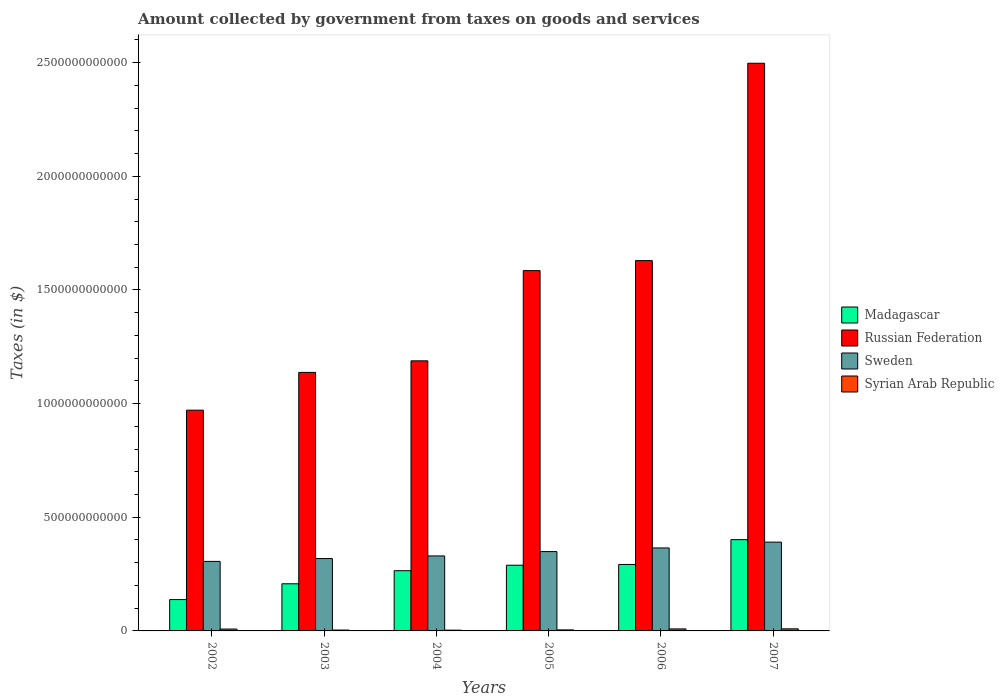How many different coloured bars are there?
Offer a very short reply. 4. How many bars are there on the 3rd tick from the right?
Offer a very short reply. 4. In how many cases, is the number of bars for a given year not equal to the number of legend labels?
Give a very brief answer. 0. What is the amount collected by government from taxes on goods and services in Madagascar in 2006?
Provide a short and direct response. 2.92e+11. Across all years, what is the maximum amount collected by government from taxes on goods and services in Sweden?
Offer a terse response. 3.91e+11. Across all years, what is the minimum amount collected by government from taxes on goods and services in Sweden?
Provide a short and direct response. 3.06e+11. What is the total amount collected by government from taxes on goods and services in Syrian Arab Republic in the graph?
Provide a succinct answer. 3.79e+1. What is the difference between the amount collected by government from taxes on goods and services in Madagascar in 2005 and that in 2007?
Keep it short and to the point. -1.12e+11. What is the difference between the amount collected by government from taxes on goods and services in Syrian Arab Republic in 2003 and the amount collected by government from taxes on goods and services in Russian Federation in 2002?
Your answer should be compact. -9.67e+11. What is the average amount collected by government from taxes on goods and services in Sweden per year?
Offer a terse response. 3.43e+11. In the year 2002, what is the difference between the amount collected by government from taxes on goods and services in Russian Federation and amount collected by government from taxes on goods and services in Sweden?
Give a very brief answer. 6.65e+11. What is the ratio of the amount collected by government from taxes on goods and services in Sweden in 2002 to that in 2004?
Your answer should be compact. 0.93. Is the amount collected by government from taxes on goods and services in Syrian Arab Republic in 2005 less than that in 2006?
Your answer should be compact. Yes. What is the difference between the highest and the second highest amount collected by government from taxes on goods and services in Sweden?
Give a very brief answer. 2.55e+1. What is the difference between the highest and the lowest amount collected by government from taxes on goods and services in Sweden?
Provide a succinct answer. 8.47e+1. Is it the case that in every year, the sum of the amount collected by government from taxes on goods and services in Russian Federation and amount collected by government from taxes on goods and services in Syrian Arab Republic is greater than the sum of amount collected by government from taxes on goods and services in Madagascar and amount collected by government from taxes on goods and services in Sweden?
Your answer should be very brief. Yes. What does the 1st bar from the left in 2006 represents?
Your answer should be compact. Madagascar. What does the 1st bar from the right in 2004 represents?
Your response must be concise. Syrian Arab Republic. Is it the case that in every year, the sum of the amount collected by government from taxes on goods and services in Russian Federation and amount collected by government from taxes on goods and services in Madagascar is greater than the amount collected by government from taxes on goods and services in Sweden?
Make the answer very short. Yes. Are all the bars in the graph horizontal?
Your answer should be compact. No. How many years are there in the graph?
Your answer should be very brief. 6. What is the difference between two consecutive major ticks on the Y-axis?
Ensure brevity in your answer.  5.00e+11. Where does the legend appear in the graph?
Your response must be concise. Center right. How are the legend labels stacked?
Make the answer very short. Vertical. What is the title of the graph?
Keep it short and to the point. Amount collected by government from taxes on goods and services. What is the label or title of the Y-axis?
Make the answer very short. Taxes (in $). What is the Taxes (in $) in Madagascar in 2002?
Your answer should be very brief. 1.38e+11. What is the Taxes (in $) of Russian Federation in 2002?
Provide a succinct answer. 9.71e+11. What is the Taxes (in $) of Sweden in 2002?
Ensure brevity in your answer.  3.06e+11. What is the Taxes (in $) in Syrian Arab Republic in 2002?
Provide a succinct answer. 8.19e+09. What is the Taxes (in $) in Madagascar in 2003?
Your response must be concise. 2.07e+11. What is the Taxes (in $) in Russian Federation in 2003?
Your response must be concise. 1.14e+12. What is the Taxes (in $) of Sweden in 2003?
Offer a very short reply. 3.18e+11. What is the Taxes (in $) of Syrian Arab Republic in 2003?
Provide a short and direct response. 3.82e+09. What is the Taxes (in $) in Madagascar in 2004?
Offer a very short reply. 2.65e+11. What is the Taxes (in $) in Russian Federation in 2004?
Provide a short and direct response. 1.19e+12. What is the Taxes (in $) of Sweden in 2004?
Ensure brevity in your answer.  3.30e+11. What is the Taxes (in $) in Syrian Arab Republic in 2004?
Make the answer very short. 3.38e+09. What is the Taxes (in $) in Madagascar in 2005?
Your response must be concise. 2.89e+11. What is the Taxes (in $) in Russian Federation in 2005?
Make the answer very short. 1.59e+12. What is the Taxes (in $) in Sweden in 2005?
Your answer should be very brief. 3.49e+11. What is the Taxes (in $) in Syrian Arab Republic in 2005?
Make the answer very short. 4.49e+09. What is the Taxes (in $) of Madagascar in 2006?
Give a very brief answer. 2.92e+11. What is the Taxes (in $) of Russian Federation in 2006?
Your answer should be compact. 1.63e+12. What is the Taxes (in $) in Sweden in 2006?
Provide a short and direct response. 3.65e+11. What is the Taxes (in $) in Syrian Arab Republic in 2006?
Your answer should be very brief. 8.83e+09. What is the Taxes (in $) of Madagascar in 2007?
Your answer should be very brief. 4.02e+11. What is the Taxes (in $) of Russian Federation in 2007?
Your response must be concise. 2.50e+12. What is the Taxes (in $) of Sweden in 2007?
Your answer should be compact. 3.91e+11. What is the Taxes (in $) in Syrian Arab Republic in 2007?
Your response must be concise. 9.14e+09. Across all years, what is the maximum Taxes (in $) of Madagascar?
Give a very brief answer. 4.02e+11. Across all years, what is the maximum Taxes (in $) in Russian Federation?
Your answer should be very brief. 2.50e+12. Across all years, what is the maximum Taxes (in $) in Sweden?
Keep it short and to the point. 3.91e+11. Across all years, what is the maximum Taxes (in $) of Syrian Arab Republic?
Give a very brief answer. 9.14e+09. Across all years, what is the minimum Taxes (in $) of Madagascar?
Ensure brevity in your answer.  1.38e+11. Across all years, what is the minimum Taxes (in $) in Russian Federation?
Give a very brief answer. 9.71e+11. Across all years, what is the minimum Taxes (in $) of Sweden?
Your answer should be very brief. 3.06e+11. Across all years, what is the minimum Taxes (in $) of Syrian Arab Republic?
Your answer should be very brief. 3.38e+09. What is the total Taxes (in $) of Madagascar in the graph?
Your answer should be very brief. 1.59e+12. What is the total Taxes (in $) in Russian Federation in the graph?
Your answer should be compact. 9.01e+12. What is the total Taxes (in $) of Sweden in the graph?
Make the answer very short. 2.06e+12. What is the total Taxes (in $) of Syrian Arab Republic in the graph?
Provide a succinct answer. 3.79e+1. What is the difference between the Taxes (in $) in Madagascar in 2002 and that in 2003?
Offer a terse response. -6.95e+1. What is the difference between the Taxes (in $) of Russian Federation in 2002 and that in 2003?
Ensure brevity in your answer.  -1.66e+11. What is the difference between the Taxes (in $) of Sweden in 2002 and that in 2003?
Keep it short and to the point. -1.25e+1. What is the difference between the Taxes (in $) of Syrian Arab Republic in 2002 and that in 2003?
Keep it short and to the point. 4.37e+09. What is the difference between the Taxes (in $) in Madagascar in 2002 and that in 2004?
Your answer should be very brief. -1.27e+11. What is the difference between the Taxes (in $) in Russian Federation in 2002 and that in 2004?
Your response must be concise. -2.17e+11. What is the difference between the Taxes (in $) of Sweden in 2002 and that in 2004?
Your answer should be compact. -2.41e+1. What is the difference between the Taxes (in $) in Syrian Arab Republic in 2002 and that in 2004?
Your answer should be very brief. 4.81e+09. What is the difference between the Taxes (in $) in Madagascar in 2002 and that in 2005?
Your answer should be very brief. -1.51e+11. What is the difference between the Taxes (in $) of Russian Federation in 2002 and that in 2005?
Give a very brief answer. -6.14e+11. What is the difference between the Taxes (in $) of Sweden in 2002 and that in 2005?
Give a very brief answer. -4.31e+1. What is the difference between the Taxes (in $) of Syrian Arab Republic in 2002 and that in 2005?
Provide a short and direct response. 3.70e+09. What is the difference between the Taxes (in $) of Madagascar in 2002 and that in 2006?
Make the answer very short. -1.54e+11. What is the difference between the Taxes (in $) in Russian Federation in 2002 and that in 2006?
Offer a very short reply. -6.58e+11. What is the difference between the Taxes (in $) of Sweden in 2002 and that in 2006?
Provide a short and direct response. -5.92e+1. What is the difference between the Taxes (in $) in Syrian Arab Republic in 2002 and that in 2006?
Ensure brevity in your answer.  -6.39e+08. What is the difference between the Taxes (in $) of Madagascar in 2002 and that in 2007?
Your answer should be compact. -2.64e+11. What is the difference between the Taxes (in $) of Russian Federation in 2002 and that in 2007?
Give a very brief answer. -1.53e+12. What is the difference between the Taxes (in $) in Sweden in 2002 and that in 2007?
Make the answer very short. -8.47e+1. What is the difference between the Taxes (in $) of Syrian Arab Republic in 2002 and that in 2007?
Keep it short and to the point. -9.52e+08. What is the difference between the Taxes (in $) in Madagascar in 2003 and that in 2004?
Provide a succinct answer. -5.76e+1. What is the difference between the Taxes (in $) of Russian Federation in 2003 and that in 2004?
Make the answer very short. -5.08e+1. What is the difference between the Taxes (in $) in Sweden in 2003 and that in 2004?
Your response must be concise. -1.16e+1. What is the difference between the Taxes (in $) in Syrian Arab Republic in 2003 and that in 2004?
Provide a short and direct response. 4.42e+08. What is the difference between the Taxes (in $) of Madagascar in 2003 and that in 2005?
Your response must be concise. -8.17e+1. What is the difference between the Taxes (in $) in Russian Federation in 2003 and that in 2005?
Provide a succinct answer. -4.48e+11. What is the difference between the Taxes (in $) in Sweden in 2003 and that in 2005?
Provide a short and direct response. -3.07e+1. What is the difference between the Taxes (in $) of Syrian Arab Republic in 2003 and that in 2005?
Your response must be concise. -6.73e+08. What is the difference between the Taxes (in $) in Madagascar in 2003 and that in 2006?
Provide a succinct answer. -8.50e+1. What is the difference between the Taxes (in $) of Russian Federation in 2003 and that in 2006?
Keep it short and to the point. -4.92e+11. What is the difference between the Taxes (in $) of Sweden in 2003 and that in 2006?
Offer a very short reply. -4.67e+1. What is the difference between the Taxes (in $) of Syrian Arab Republic in 2003 and that in 2006?
Ensure brevity in your answer.  -5.01e+09. What is the difference between the Taxes (in $) of Madagascar in 2003 and that in 2007?
Provide a succinct answer. -1.94e+11. What is the difference between the Taxes (in $) of Russian Federation in 2003 and that in 2007?
Ensure brevity in your answer.  -1.36e+12. What is the difference between the Taxes (in $) of Sweden in 2003 and that in 2007?
Your answer should be very brief. -7.22e+1. What is the difference between the Taxes (in $) in Syrian Arab Republic in 2003 and that in 2007?
Provide a short and direct response. -5.32e+09. What is the difference between the Taxes (in $) of Madagascar in 2004 and that in 2005?
Offer a terse response. -2.41e+1. What is the difference between the Taxes (in $) of Russian Federation in 2004 and that in 2005?
Keep it short and to the point. -3.97e+11. What is the difference between the Taxes (in $) in Sweden in 2004 and that in 2005?
Offer a very short reply. -1.91e+1. What is the difference between the Taxes (in $) in Syrian Arab Republic in 2004 and that in 2005?
Offer a terse response. -1.12e+09. What is the difference between the Taxes (in $) in Madagascar in 2004 and that in 2006?
Make the answer very short. -2.74e+1. What is the difference between the Taxes (in $) of Russian Federation in 2004 and that in 2006?
Give a very brief answer. -4.41e+11. What is the difference between the Taxes (in $) of Sweden in 2004 and that in 2006?
Ensure brevity in your answer.  -3.51e+1. What is the difference between the Taxes (in $) in Syrian Arab Republic in 2004 and that in 2006?
Your answer should be compact. -5.45e+09. What is the difference between the Taxes (in $) in Madagascar in 2004 and that in 2007?
Offer a very short reply. -1.37e+11. What is the difference between the Taxes (in $) in Russian Federation in 2004 and that in 2007?
Your response must be concise. -1.31e+12. What is the difference between the Taxes (in $) in Sweden in 2004 and that in 2007?
Ensure brevity in your answer.  -6.07e+1. What is the difference between the Taxes (in $) of Syrian Arab Republic in 2004 and that in 2007?
Your answer should be compact. -5.77e+09. What is the difference between the Taxes (in $) in Madagascar in 2005 and that in 2006?
Ensure brevity in your answer.  -3.30e+09. What is the difference between the Taxes (in $) of Russian Federation in 2005 and that in 2006?
Your answer should be compact. -4.41e+1. What is the difference between the Taxes (in $) of Sweden in 2005 and that in 2006?
Your answer should be compact. -1.60e+1. What is the difference between the Taxes (in $) in Syrian Arab Republic in 2005 and that in 2006?
Offer a terse response. -4.34e+09. What is the difference between the Taxes (in $) of Madagascar in 2005 and that in 2007?
Offer a terse response. -1.12e+11. What is the difference between the Taxes (in $) of Russian Federation in 2005 and that in 2007?
Provide a succinct answer. -9.12e+11. What is the difference between the Taxes (in $) in Sweden in 2005 and that in 2007?
Provide a short and direct response. -4.16e+1. What is the difference between the Taxes (in $) of Syrian Arab Republic in 2005 and that in 2007?
Your answer should be very brief. -4.65e+09. What is the difference between the Taxes (in $) in Madagascar in 2006 and that in 2007?
Your answer should be compact. -1.09e+11. What is the difference between the Taxes (in $) in Russian Federation in 2006 and that in 2007?
Provide a short and direct response. -8.68e+11. What is the difference between the Taxes (in $) in Sweden in 2006 and that in 2007?
Make the answer very short. -2.55e+1. What is the difference between the Taxes (in $) of Syrian Arab Republic in 2006 and that in 2007?
Make the answer very short. -3.13e+08. What is the difference between the Taxes (in $) in Madagascar in 2002 and the Taxes (in $) in Russian Federation in 2003?
Ensure brevity in your answer.  -9.99e+11. What is the difference between the Taxes (in $) in Madagascar in 2002 and the Taxes (in $) in Sweden in 2003?
Provide a short and direct response. -1.80e+11. What is the difference between the Taxes (in $) of Madagascar in 2002 and the Taxes (in $) of Syrian Arab Republic in 2003?
Provide a succinct answer. 1.34e+11. What is the difference between the Taxes (in $) of Russian Federation in 2002 and the Taxes (in $) of Sweden in 2003?
Provide a succinct answer. 6.53e+11. What is the difference between the Taxes (in $) in Russian Federation in 2002 and the Taxes (in $) in Syrian Arab Republic in 2003?
Offer a terse response. 9.67e+11. What is the difference between the Taxes (in $) in Sweden in 2002 and the Taxes (in $) in Syrian Arab Republic in 2003?
Offer a very short reply. 3.02e+11. What is the difference between the Taxes (in $) in Madagascar in 2002 and the Taxes (in $) in Russian Federation in 2004?
Offer a very short reply. -1.05e+12. What is the difference between the Taxes (in $) of Madagascar in 2002 and the Taxes (in $) of Sweden in 2004?
Your answer should be very brief. -1.92e+11. What is the difference between the Taxes (in $) of Madagascar in 2002 and the Taxes (in $) of Syrian Arab Republic in 2004?
Offer a terse response. 1.35e+11. What is the difference between the Taxes (in $) in Russian Federation in 2002 and the Taxes (in $) in Sweden in 2004?
Your response must be concise. 6.41e+11. What is the difference between the Taxes (in $) of Russian Federation in 2002 and the Taxes (in $) of Syrian Arab Republic in 2004?
Your answer should be very brief. 9.68e+11. What is the difference between the Taxes (in $) of Sweden in 2002 and the Taxes (in $) of Syrian Arab Republic in 2004?
Your answer should be compact. 3.02e+11. What is the difference between the Taxes (in $) in Madagascar in 2002 and the Taxes (in $) in Russian Federation in 2005?
Give a very brief answer. -1.45e+12. What is the difference between the Taxes (in $) in Madagascar in 2002 and the Taxes (in $) in Sweden in 2005?
Give a very brief answer. -2.11e+11. What is the difference between the Taxes (in $) of Madagascar in 2002 and the Taxes (in $) of Syrian Arab Republic in 2005?
Make the answer very short. 1.33e+11. What is the difference between the Taxes (in $) of Russian Federation in 2002 and the Taxes (in $) of Sweden in 2005?
Make the answer very short. 6.22e+11. What is the difference between the Taxes (in $) of Russian Federation in 2002 and the Taxes (in $) of Syrian Arab Republic in 2005?
Provide a short and direct response. 9.67e+11. What is the difference between the Taxes (in $) of Sweden in 2002 and the Taxes (in $) of Syrian Arab Republic in 2005?
Your answer should be compact. 3.01e+11. What is the difference between the Taxes (in $) in Madagascar in 2002 and the Taxes (in $) in Russian Federation in 2006?
Provide a short and direct response. -1.49e+12. What is the difference between the Taxes (in $) of Madagascar in 2002 and the Taxes (in $) of Sweden in 2006?
Provide a short and direct response. -2.27e+11. What is the difference between the Taxes (in $) of Madagascar in 2002 and the Taxes (in $) of Syrian Arab Republic in 2006?
Your response must be concise. 1.29e+11. What is the difference between the Taxes (in $) of Russian Federation in 2002 and the Taxes (in $) of Sweden in 2006?
Your answer should be compact. 6.06e+11. What is the difference between the Taxes (in $) in Russian Federation in 2002 and the Taxes (in $) in Syrian Arab Republic in 2006?
Give a very brief answer. 9.62e+11. What is the difference between the Taxes (in $) of Sweden in 2002 and the Taxes (in $) of Syrian Arab Republic in 2006?
Provide a succinct answer. 2.97e+11. What is the difference between the Taxes (in $) of Madagascar in 2002 and the Taxes (in $) of Russian Federation in 2007?
Make the answer very short. -2.36e+12. What is the difference between the Taxes (in $) in Madagascar in 2002 and the Taxes (in $) in Sweden in 2007?
Your answer should be compact. -2.53e+11. What is the difference between the Taxes (in $) of Madagascar in 2002 and the Taxes (in $) of Syrian Arab Republic in 2007?
Provide a succinct answer. 1.29e+11. What is the difference between the Taxes (in $) of Russian Federation in 2002 and the Taxes (in $) of Sweden in 2007?
Offer a terse response. 5.81e+11. What is the difference between the Taxes (in $) of Russian Federation in 2002 and the Taxes (in $) of Syrian Arab Republic in 2007?
Give a very brief answer. 9.62e+11. What is the difference between the Taxes (in $) of Sweden in 2002 and the Taxes (in $) of Syrian Arab Republic in 2007?
Give a very brief answer. 2.97e+11. What is the difference between the Taxes (in $) in Madagascar in 2003 and the Taxes (in $) in Russian Federation in 2004?
Provide a succinct answer. -9.81e+11. What is the difference between the Taxes (in $) in Madagascar in 2003 and the Taxes (in $) in Sweden in 2004?
Make the answer very short. -1.23e+11. What is the difference between the Taxes (in $) of Madagascar in 2003 and the Taxes (in $) of Syrian Arab Republic in 2004?
Your response must be concise. 2.04e+11. What is the difference between the Taxes (in $) in Russian Federation in 2003 and the Taxes (in $) in Sweden in 2004?
Offer a very short reply. 8.07e+11. What is the difference between the Taxes (in $) in Russian Federation in 2003 and the Taxes (in $) in Syrian Arab Republic in 2004?
Provide a succinct answer. 1.13e+12. What is the difference between the Taxes (in $) in Sweden in 2003 and the Taxes (in $) in Syrian Arab Republic in 2004?
Make the answer very short. 3.15e+11. What is the difference between the Taxes (in $) of Madagascar in 2003 and the Taxes (in $) of Russian Federation in 2005?
Your answer should be very brief. -1.38e+12. What is the difference between the Taxes (in $) of Madagascar in 2003 and the Taxes (in $) of Sweden in 2005?
Provide a short and direct response. -1.42e+11. What is the difference between the Taxes (in $) in Madagascar in 2003 and the Taxes (in $) in Syrian Arab Republic in 2005?
Keep it short and to the point. 2.03e+11. What is the difference between the Taxes (in $) of Russian Federation in 2003 and the Taxes (in $) of Sweden in 2005?
Make the answer very short. 7.88e+11. What is the difference between the Taxes (in $) of Russian Federation in 2003 and the Taxes (in $) of Syrian Arab Republic in 2005?
Your answer should be compact. 1.13e+12. What is the difference between the Taxes (in $) in Sweden in 2003 and the Taxes (in $) in Syrian Arab Republic in 2005?
Provide a succinct answer. 3.14e+11. What is the difference between the Taxes (in $) in Madagascar in 2003 and the Taxes (in $) in Russian Federation in 2006?
Keep it short and to the point. -1.42e+12. What is the difference between the Taxes (in $) in Madagascar in 2003 and the Taxes (in $) in Sweden in 2006?
Make the answer very short. -1.58e+11. What is the difference between the Taxes (in $) in Madagascar in 2003 and the Taxes (in $) in Syrian Arab Republic in 2006?
Give a very brief answer. 1.99e+11. What is the difference between the Taxes (in $) in Russian Federation in 2003 and the Taxes (in $) in Sweden in 2006?
Offer a terse response. 7.72e+11. What is the difference between the Taxes (in $) in Russian Federation in 2003 and the Taxes (in $) in Syrian Arab Republic in 2006?
Your response must be concise. 1.13e+12. What is the difference between the Taxes (in $) in Sweden in 2003 and the Taxes (in $) in Syrian Arab Republic in 2006?
Your answer should be compact. 3.10e+11. What is the difference between the Taxes (in $) in Madagascar in 2003 and the Taxes (in $) in Russian Federation in 2007?
Provide a short and direct response. -2.29e+12. What is the difference between the Taxes (in $) of Madagascar in 2003 and the Taxes (in $) of Sweden in 2007?
Your response must be concise. -1.83e+11. What is the difference between the Taxes (in $) in Madagascar in 2003 and the Taxes (in $) in Syrian Arab Republic in 2007?
Offer a very short reply. 1.98e+11. What is the difference between the Taxes (in $) in Russian Federation in 2003 and the Taxes (in $) in Sweden in 2007?
Make the answer very short. 7.47e+11. What is the difference between the Taxes (in $) of Russian Federation in 2003 and the Taxes (in $) of Syrian Arab Republic in 2007?
Give a very brief answer. 1.13e+12. What is the difference between the Taxes (in $) of Sweden in 2003 and the Taxes (in $) of Syrian Arab Republic in 2007?
Ensure brevity in your answer.  3.09e+11. What is the difference between the Taxes (in $) in Madagascar in 2004 and the Taxes (in $) in Russian Federation in 2005?
Offer a very short reply. -1.32e+12. What is the difference between the Taxes (in $) of Madagascar in 2004 and the Taxes (in $) of Sweden in 2005?
Keep it short and to the point. -8.40e+1. What is the difference between the Taxes (in $) of Madagascar in 2004 and the Taxes (in $) of Syrian Arab Republic in 2005?
Provide a short and direct response. 2.60e+11. What is the difference between the Taxes (in $) in Russian Federation in 2004 and the Taxes (in $) in Sweden in 2005?
Offer a terse response. 8.39e+11. What is the difference between the Taxes (in $) in Russian Federation in 2004 and the Taxes (in $) in Syrian Arab Republic in 2005?
Provide a succinct answer. 1.18e+12. What is the difference between the Taxes (in $) of Sweden in 2004 and the Taxes (in $) of Syrian Arab Republic in 2005?
Offer a very short reply. 3.25e+11. What is the difference between the Taxes (in $) in Madagascar in 2004 and the Taxes (in $) in Russian Federation in 2006?
Your answer should be compact. -1.36e+12. What is the difference between the Taxes (in $) of Madagascar in 2004 and the Taxes (in $) of Sweden in 2006?
Your answer should be very brief. -1.00e+11. What is the difference between the Taxes (in $) of Madagascar in 2004 and the Taxes (in $) of Syrian Arab Republic in 2006?
Make the answer very short. 2.56e+11. What is the difference between the Taxes (in $) of Russian Federation in 2004 and the Taxes (in $) of Sweden in 2006?
Your answer should be very brief. 8.23e+11. What is the difference between the Taxes (in $) in Russian Federation in 2004 and the Taxes (in $) in Syrian Arab Republic in 2006?
Your response must be concise. 1.18e+12. What is the difference between the Taxes (in $) in Sweden in 2004 and the Taxes (in $) in Syrian Arab Republic in 2006?
Make the answer very short. 3.21e+11. What is the difference between the Taxes (in $) of Madagascar in 2004 and the Taxes (in $) of Russian Federation in 2007?
Give a very brief answer. -2.23e+12. What is the difference between the Taxes (in $) of Madagascar in 2004 and the Taxes (in $) of Sweden in 2007?
Ensure brevity in your answer.  -1.26e+11. What is the difference between the Taxes (in $) of Madagascar in 2004 and the Taxes (in $) of Syrian Arab Republic in 2007?
Provide a succinct answer. 2.56e+11. What is the difference between the Taxes (in $) of Russian Federation in 2004 and the Taxes (in $) of Sweden in 2007?
Give a very brief answer. 7.98e+11. What is the difference between the Taxes (in $) of Russian Federation in 2004 and the Taxes (in $) of Syrian Arab Republic in 2007?
Your answer should be very brief. 1.18e+12. What is the difference between the Taxes (in $) of Sweden in 2004 and the Taxes (in $) of Syrian Arab Republic in 2007?
Offer a terse response. 3.21e+11. What is the difference between the Taxes (in $) of Madagascar in 2005 and the Taxes (in $) of Russian Federation in 2006?
Your response must be concise. -1.34e+12. What is the difference between the Taxes (in $) of Madagascar in 2005 and the Taxes (in $) of Sweden in 2006?
Offer a very short reply. -7.60e+1. What is the difference between the Taxes (in $) in Madagascar in 2005 and the Taxes (in $) in Syrian Arab Republic in 2006?
Provide a succinct answer. 2.80e+11. What is the difference between the Taxes (in $) in Russian Federation in 2005 and the Taxes (in $) in Sweden in 2006?
Give a very brief answer. 1.22e+12. What is the difference between the Taxes (in $) of Russian Federation in 2005 and the Taxes (in $) of Syrian Arab Republic in 2006?
Keep it short and to the point. 1.58e+12. What is the difference between the Taxes (in $) in Sweden in 2005 and the Taxes (in $) in Syrian Arab Republic in 2006?
Offer a terse response. 3.40e+11. What is the difference between the Taxes (in $) of Madagascar in 2005 and the Taxes (in $) of Russian Federation in 2007?
Ensure brevity in your answer.  -2.21e+12. What is the difference between the Taxes (in $) in Madagascar in 2005 and the Taxes (in $) in Sweden in 2007?
Make the answer very short. -1.02e+11. What is the difference between the Taxes (in $) of Madagascar in 2005 and the Taxes (in $) of Syrian Arab Republic in 2007?
Offer a terse response. 2.80e+11. What is the difference between the Taxes (in $) in Russian Federation in 2005 and the Taxes (in $) in Sweden in 2007?
Provide a short and direct response. 1.19e+12. What is the difference between the Taxes (in $) of Russian Federation in 2005 and the Taxes (in $) of Syrian Arab Republic in 2007?
Ensure brevity in your answer.  1.58e+12. What is the difference between the Taxes (in $) in Sweden in 2005 and the Taxes (in $) in Syrian Arab Republic in 2007?
Keep it short and to the point. 3.40e+11. What is the difference between the Taxes (in $) in Madagascar in 2006 and the Taxes (in $) in Russian Federation in 2007?
Keep it short and to the point. -2.20e+12. What is the difference between the Taxes (in $) of Madagascar in 2006 and the Taxes (in $) of Sweden in 2007?
Make the answer very short. -9.82e+1. What is the difference between the Taxes (in $) of Madagascar in 2006 and the Taxes (in $) of Syrian Arab Republic in 2007?
Your answer should be compact. 2.83e+11. What is the difference between the Taxes (in $) of Russian Federation in 2006 and the Taxes (in $) of Sweden in 2007?
Your answer should be very brief. 1.24e+12. What is the difference between the Taxes (in $) of Russian Federation in 2006 and the Taxes (in $) of Syrian Arab Republic in 2007?
Give a very brief answer. 1.62e+12. What is the difference between the Taxes (in $) of Sweden in 2006 and the Taxes (in $) of Syrian Arab Republic in 2007?
Provide a succinct answer. 3.56e+11. What is the average Taxes (in $) of Madagascar per year?
Your response must be concise. 2.66e+11. What is the average Taxes (in $) in Russian Federation per year?
Ensure brevity in your answer.  1.50e+12. What is the average Taxes (in $) in Sweden per year?
Make the answer very short. 3.43e+11. What is the average Taxes (in $) in Syrian Arab Republic per year?
Offer a terse response. 6.31e+09. In the year 2002, what is the difference between the Taxes (in $) in Madagascar and Taxes (in $) in Russian Federation?
Provide a short and direct response. -8.33e+11. In the year 2002, what is the difference between the Taxes (in $) in Madagascar and Taxes (in $) in Sweden?
Your answer should be compact. -1.68e+11. In the year 2002, what is the difference between the Taxes (in $) in Madagascar and Taxes (in $) in Syrian Arab Republic?
Your response must be concise. 1.30e+11. In the year 2002, what is the difference between the Taxes (in $) of Russian Federation and Taxes (in $) of Sweden?
Keep it short and to the point. 6.65e+11. In the year 2002, what is the difference between the Taxes (in $) of Russian Federation and Taxes (in $) of Syrian Arab Republic?
Offer a very short reply. 9.63e+11. In the year 2002, what is the difference between the Taxes (in $) of Sweden and Taxes (in $) of Syrian Arab Republic?
Offer a terse response. 2.98e+11. In the year 2003, what is the difference between the Taxes (in $) of Madagascar and Taxes (in $) of Russian Federation?
Your answer should be compact. -9.30e+11. In the year 2003, what is the difference between the Taxes (in $) of Madagascar and Taxes (in $) of Sweden?
Provide a succinct answer. -1.11e+11. In the year 2003, what is the difference between the Taxes (in $) in Madagascar and Taxes (in $) in Syrian Arab Republic?
Offer a very short reply. 2.04e+11. In the year 2003, what is the difference between the Taxes (in $) of Russian Federation and Taxes (in $) of Sweden?
Keep it short and to the point. 8.19e+11. In the year 2003, what is the difference between the Taxes (in $) in Russian Federation and Taxes (in $) in Syrian Arab Republic?
Offer a very short reply. 1.13e+12. In the year 2003, what is the difference between the Taxes (in $) of Sweden and Taxes (in $) of Syrian Arab Republic?
Give a very brief answer. 3.15e+11. In the year 2004, what is the difference between the Taxes (in $) in Madagascar and Taxes (in $) in Russian Federation?
Offer a terse response. -9.23e+11. In the year 2004, what is the difference between the Taxes (in $) in Madagascar and Taxes (in $) in Sweden?
Make the answer very short. -6.50e+1. In the year 2004, what is the difference between the Taxes (in $) in Madagascar and Taxes (in $) in Syrian Arab Republic?
Provide a succinct answer. 2.62e+11. In the year 2004, what is the difference between the Taxes (in $) in Russian Federation and Taxes (in $) in Sweden?
Your answer should be very brief. 8.58e+11. In the year 2004, what is the difference between the Taxes (in $) in Russian Federation and Taxes (in $) in Syrian Arab Republic?
Your response must be concise. 1.18e+12. In the year 2004, what is the difference between the Taxes (in $) in Sweden and Taxes (in $) in Syrian Arab Republic?
Your answer should be very brief. 3.27e+11. In the year 2005, what is the difference between the Taxes (in $) of Madagascar and Taxes (in $) of Russian Federation?
Ensure brevity in your answer.  -1.30e+12. In the year 2005, what is the difference between the Taxes (in $) of Madagascar and Taxes (in $) of Sweden?
Ensure brevity in your answer.  -5.99e+1. In the year 2005, what is the difference between the Taxes (in $) of Madagascar and Taxes (in $) of Syrian Arab Republic?
Your answer should be very brief. 2.85e+11. In the year 2005, what is the difference between the Taxes (in $) of Russian Federation and Taxes (in $) of Sweden?
Provide a succinct answer. 1.24e+12. In the year 2005, what is the difference between the Taxes (in $) of Russian Federation and Taxes (in $) of Syrian Arab Republic?
Offer a terse response. 1.58e+12. In the year 2005, what is the difference between the Taxes (in $) of Sweden and Taxes (in $) of Syrian Arab Republic?
Your answer should be compact. 3.45e+11. In the year 2006, what is the difference between the Taxes (in $) of Madagascar and Taxes (in $) of Russian Federation?
Your response must be concise. -1.34e+12. In the year 2006, what is the difference between the Taxes (in $) in Madagascar and Taxes (in $) in Sweden?
Provide a short and direct response. -7.27e+1. In the year 2006, what is the difference between the Taxes (in $) of Madagascar and Taxes (in $) of Syrian Arab Republic?
Your answer should be very brief. 2.84e+11. In the year 2006, what is the difference between the Taxes (in $) in Russian Federation and Taxes (in $) in Sweden?
Your answer should be very brief. 1.26e+12. In the year 2006, what is the difference between the Taxes (in $) in Russian Federation and Taxes (in $) in Syrian Arab Republic?
Keep it short and to the point. 1.62e+12. In the year 2006, what is the difference between the Taxes (in $) of Sweden and Taxes (in $) of Syrian Arab Republic?
Your response must be concise. 3.56e+11. In the year 2007, what is the difference between the Taxes (in $) in Madagascar and Taxes (in $) in Russian Federation?
Ensure brevity in your answer.  -2.10e+12. In the year 2007, what is the difference between the Taxes (in $) of Madagascar and Taxes (in $) of Sweden?
Make the answer very short. 1.10e+1. In the year 2007, what is the difference between the Taxes (in $) of Madagascar and Taxes (in $) of Syrian Arab Republic?
Provide a short and direct response. 3.92e+11. In the year 2007, what is the difference between the Taxes (in $) of Russian Federation and Taxes (in $) of Sweden?
Keep it short and to the point. 2.11e+12. In the year 2007, what is the difference between the Taxes (in $) of Russian Federation and Taxes (in $) of Syrian Arab Republic?
Offer a very short reply. 2.49e+12. In the year 2007, what is the difference between the Taxes (in $) of Sweden and Taxes (in $) of Syrian Arab Republic?
Offer a terse response. 3.81e+11. What is the ratio of the Taxes (in $) in Madagascar in 2002 to that in 2003?
Keep it short and to the point. 0.67. What is the ratio of the Taxes (in $) in Russian Federation in 2002 to that in 2003?
Ensure brevity in your answer.  0.85. What is the ratio of the Taxes (in $) of Sweden in 2002 to that in 2003?
Your answer should be compact. 0.96. What is the ratio of the Taxes (in $) in Syrian Arab Republic in 2002 to that in 2003?
Your response must be concise. 2.14. What is the ratio of the Taxes (in $) of Madagascar in 2002 to that in 2004?
Your answer should be compact. 0.52. What is the ratio of the Taxes (in $) in Russian Federation in 2002 to that in 2004?
Your answer should be compact. 0.82. What is the ratio of the Taxes (in $) in Sweden in 2002 to that in 2004?
Your answer should be very brief. 0.93. What is the ratio of the Taxes (in $) in Syrian Arab Republic in 2002 to that in 2004?
Provide a short and direct response. 2.42. What is the ratio of the Taxes (in $) in Madagascar in 2002 to that in 2005?
Give a very brief answer. 0.48. What is the ratio of the Taxes (in $) in Russian Federation in 2002 to that in 2005?
Your response must be concise. 0.61. What is the ratio of the Taxes (in $) in Sweden in 2002 to that in 2005?
Give a very brief answer. 0.88. What is the ratio of the Taxes (in $) of Syrian Arab Republic in 2002 to that in 2005?
Provide a succinct answer. 1.82. What is the ratio of the Taxes (in $) in Madagascar in 2002 to that in 2006?
Offer a very short reply. 0.47. What is the ratio of the Taxes (in $) in Russian Federation in 2002 to that in 2006?
Ensure brevity in your answer.  0.6. What is the ratio of the Taxes (in $) of Sweden in 2002 to that in 2006?
Give a very brief answer. 0.84. What is the ratio of the Taxes (in $) of Syrian Arab Republic in 2002 to that in 2006?
Provide a short and direct response. 0.93. What is the ratio of the Taxes (in $) in Madagascar in 2002 to that in 2007?
Provide a short and direct response. 0.34. What is the ratio of the Taxes (in $) of Russian Federation in 2002 to that in 2007?
Ensure brevity in your answer.  0.39. What is the ratio of the Taxes (in $) of Sweden in 2002 to that in 2007?
Your response must be concise. 0.78. What is the ratio of the Taxes (in $) of Syrian Arab Republic in 2002 to that in 2007?
Make the answer very short. 0.9. What is the ratio of the Taxes (in $) of Madagascar in 2003 to that in 2004?
Make the answer very short. 0.78. What is the ratio of the Taxes (in $) in Russian Federation in 2003 to that in 2004?
Offer a terse response. 0.96. What is the ratio of the Taxes (in $) of Syrian Arab Republic in 2003 to that in 2004?
Ensure brevity in your answer.  1.13. What is the ratio of the Taxes (in $) in Madagascar in 2003 to that in 2005?
Your answer should be compact. 0.72. What is the ratio of the Taxes (in $) in Russian Federation in 2003 to that in 2005?
Your answer should be compact. 0.72. What is the ratio of the Taxes (in $) of Sweden in 2003 to that in 2005?
Ensure brevity in your answer.  0.91. What is the ratio of the Taxes (in $) of Syrian Arab Republic in 2003 to that in 2005?
Your answer should be compact. 0.85. What is the ratio of the Taxes (in $) of Madagascar in 2003 to that in 2006?
Your answer should be very brief. 0.71. What is the ratio of the Taxes (in $) of Russian Federation in 2003 to that in 2006?
Your response must be concise. 0.7. What is the ratio of the Taxes (in $) in Sweden in 2003 to that in 2006?
Make the answer very short. 0.87. What is the ratio of the Taxes (in $) in Syrian Arab Republic in 2003 to that in 2006?
Ensure brevity in your answer.  0.43. What is the ratio of the Taxes (in $) in Madagascar in 2003 to that in 2007?
Offer a very short reply. 0.52. What is the ratio of the Taxes (in $) in Russian Federation in 2003 to that in 2007?
Provide a succinct answer. 0.46. What is the ratio of the Taxes (in $) of Sweden in 2003 to that in 2007?
Offer a very short reply. 0.82. What is the ratio of the Taxes (in $) in Syrian Arab Republic in 2003 to that in 2007?
Your response must be concise. 0.42. What is the ratio of the Taxes (in $) of Madagascar in 2004 to that in 2005?
Make the answer very short. 0.92. What is the ratio of the Taxes (in $) in Russian Federation in 2004 to that in 2005?
Your answer should be compact. 0.75. What is the ratio of the Taxes (in $) in Sweden in 2004 to that in 2005?
Your answer should be very brief. 0.95. What is the ratio of the Taxes (in $) of Syrian Arab Republic in 2004 to that in 2005?
Provide a short and direct response. 0.75. What is the ratio of the Taxes (in $) in Madagascar in 2004 to that in 2006?
Your answer should be compact. 0.91. What is the ratio of the Taxes (in $) in Russian Federation in 2004 to that in 2006?
Keep it short and to the point. 0.73. What is the ratio of the Taxes (in $) in Sweden in 2004 to that in 2006?
Offer a terse response. 0.9. What is the ratio of the Taxes (in $) in Syrian Arab Republic in 2004 to that in 2006?
Offer a terse response. 0.38. What is the ratio of the Taxes (in $) of Madagascar in 2004 to that in 2007?
Your response must be concise. 0.66. What is the ratio of the Taxes (in $) of Russian Federation in 2004 to that in 2007?
Offer a very short reply. 0.48. What is the ratio of the Taxes (in $) in Sweden in 2004 to that in 2007?
Ensure brevity in your answer.  0.84. What is the ratio of the Taxes (in $) of Syrian Arab Republic in 2004 to that in 2007?
Keep it short and to the point. 0.37. What is the ratio of the Taxes (in $) in Madagascar in 2005 to that in 2006?
Keep it short and to the point. 0.99. What is the ratio of the Taxes (in $) in Sweden in 2005 to that in 2006?
Offer a very short reply. 0.96. What is the ratio of the Taxes (in $) of Syrian Arab Republic in 2005 to that in 2006?
Offer a terse response. 0.51. What is the ratio of the Taxes (in $) of Madagascar in 2005 to that in 2007?
Make the answer very short. 0.72. What is the ratio of the Taxes (in $) in Russian Federation in 2005 to that in 2007?
Keep it short and to the point. 0.63. What is the ratio of the Taxes (in $) in Sweden in 2005 to that in 2007?
Provide a succinct answer. 0.89. What is the ratio of the Taxes (in $) of Syrian Arab Republic in 2005 to that in 2007?
Your answer should be very brief. 0.49. What is the ratio of the Taxes (in $) of Madagascar in 2006 to that in 2007?
Give a very brief answer. 0.73. What is the ratio of the Taxes (in $) in Russian Federation in 2006 to that in 2007?
Offer a very short reply. 0.65. What is the ratio of the Taxes (in $) in Sweden in 2006 to that in 2007?
Provide a short and direct response. 0.93. What is the ratio of the Taxes (in $) in Syrian Arab Republic in 2006 to that in 2007?
Your response must be concise. 0.97. What is the difference between the highest and the second highest Taxes (in $) in Madagascar?
Provide a short and direct response. 1.09e+11. What is the difference between the highest and the second highest Taxes (in $) of Russian Federation?
Your answer should be very brief. 8.68e+11. What is the difference between the highest and the second highest Taxes (in $) of Sweden?
Provide a short and direct response. 2.55e+1. What is the difference between the highest and the second highest Taxes (in $) of Syrian Arab Republic?
Your response must be concise. 3.13e+08. What is the difference between the highest and the lowest Taxes (in $) of Madagascar?
Make the answer very short. 2.64e+11. What is the difference between the highest and the lowest Taxes (in $) of Russian Federation?
Offer a very short reply. 1.53e+12. What is the difference between the highest and the lowest Taxes (in $) of Sweden?
Provide a short and direct response. 8.47e+1. What is the difference between the highest and the lowest Taxes (in $) of Syrian Arab Republic?
Offer a very short reply. 5.77e+09. 